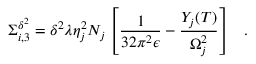Convert formula to latex. <formula><loc_0><loc_0><loc_500><loc_500>\Sigma _ { i , 3 } ^ { \delta ^ { 2 } } = \delta ^ { 2 } \lambda \eta _ { j } ^ { 2 } N _ { j } \left [ \frac { 1 } { 3 2 \pi ^ { 2 } \epsilon } - \frac { Y _ { j } ( T ) } { \Omega _ { j } ^ { 2 } } \right ] \, .</formula> 